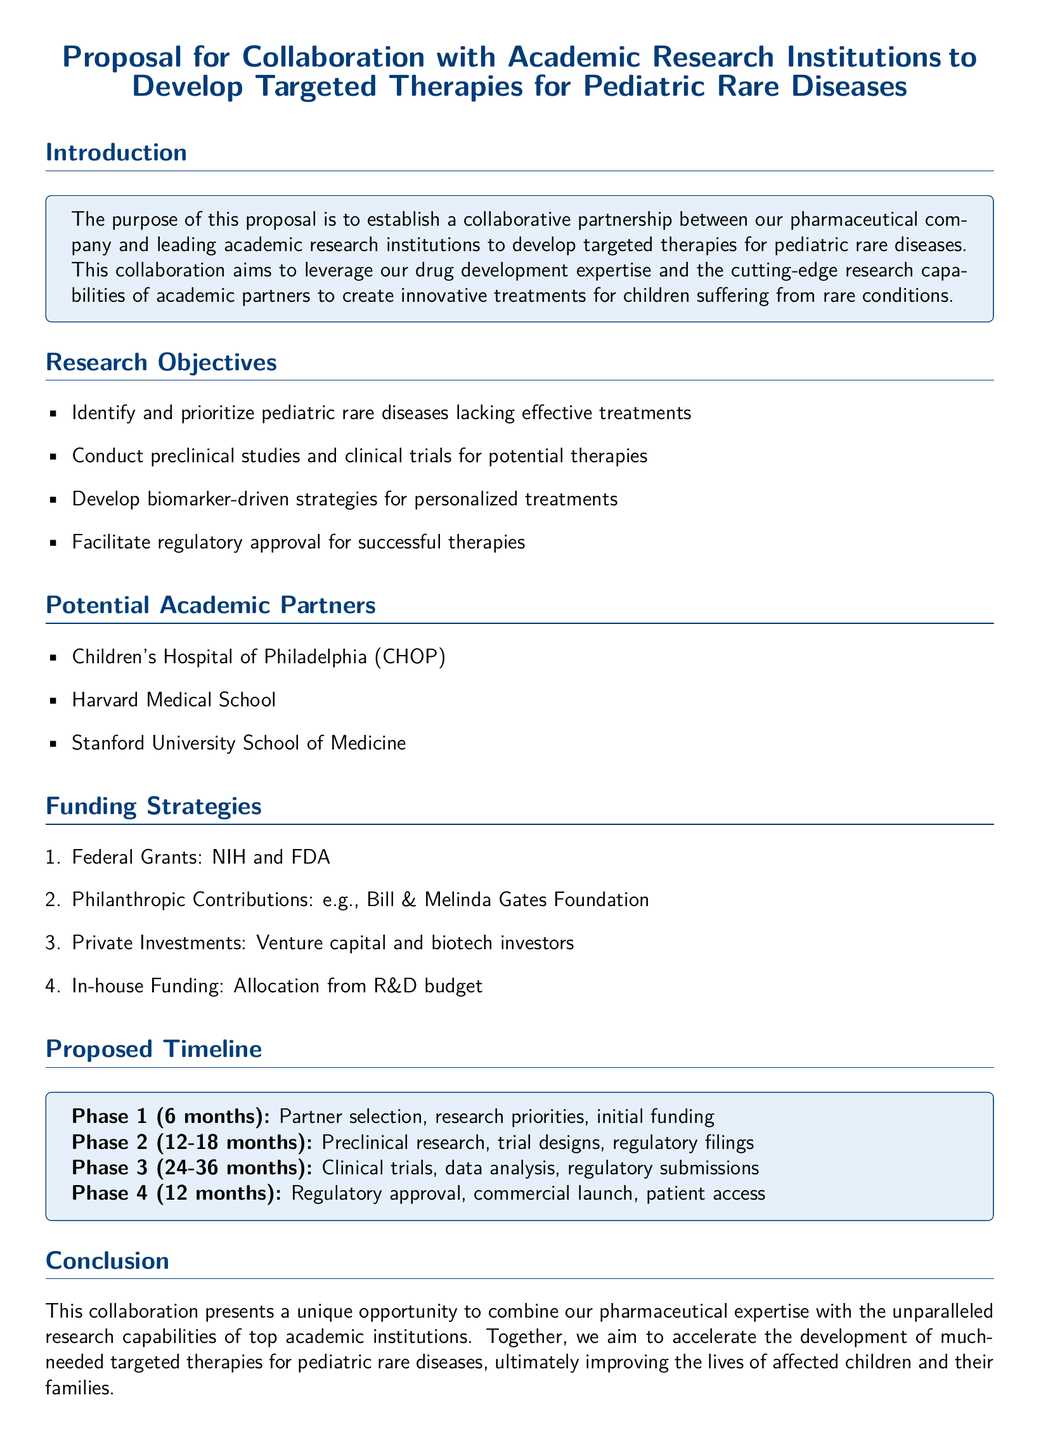what is the main purpose of the proposal? The main purpose of the proposal is to establish a collaborative partnership to develop targeted therapies for pediatric rare diseases.
Answer: establish a collaborative partnership how many phases are proposed in the timeline? The proposed timeline includes four distinct phases.
Answer: 4 which institutions are potential academic partners? The document lists three potential academic partners, which include the Children's Hospital of Philadelphia, Harvard Medical School, and Stanford University School of Medicine.
Answer: Children's Hospital of Philadelphia, Harvard Medical School, Stanford University School of Medicine what is the duration of Phase 1? The duration of Phase 1 is specified as six months.
Answer: 6 months which funding strategy involves private entities? The funding strategy that involves private entities is private investments.
Answer: private investments what is one of the research objectives? One of the research objectives is to identify and prioritize pediatric rare diseases lacking effective treatments.
Answer: identify and prioritize pediatric rare diseases lacking effective treatments how long is Phase 2 scheduled to take? Phase 2 is scheduled to take between 12 to 18 months.
Answer: 12-18 months what type of grants are mentioned as a funding strategy? Federal grants are mentioned as a funding strategy in the proposal.
Answer: Federal Grants what is the final phase focused on? The final phase focuses on regulatory approval, commercial launch, and patient access.
Answer: regulatory approval, commercial launch, patient access 